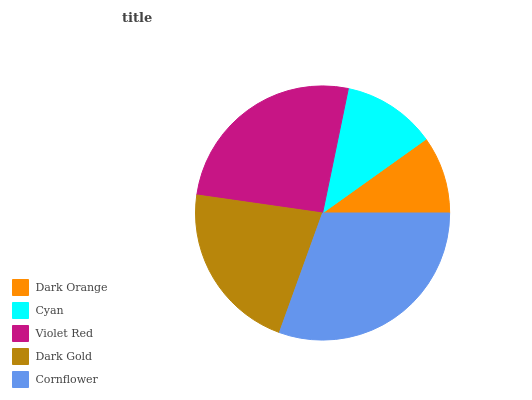Is Dark Orange the minimum?
Answer yes or no. Yes. Is Cornflower the maximum?
Answer yes or no. Yes. Is Cyan the minimum?
Answer yes or no. No. Is Cyan the maximum?
Answer yes or no. No. Is Cyan greater than Dark Orange?
Answer yes or no. Yes. Is Dark Orange less than Cyan?
Answer yes or no. Yes. Is Dark Orange greater than Cyan?
Answer yes or no. No. Is Cyan less than Dark Orange?
Answer yes or no. No. Is Dark Gold the high median?
Answer yes or no. Yes. Is Dark Gold the low median?
Answer yes or no. Yes. Is Violet Red the high median?
Answer yes or no. No. Is Cornflower the low median?
Answer yes or no. No. 